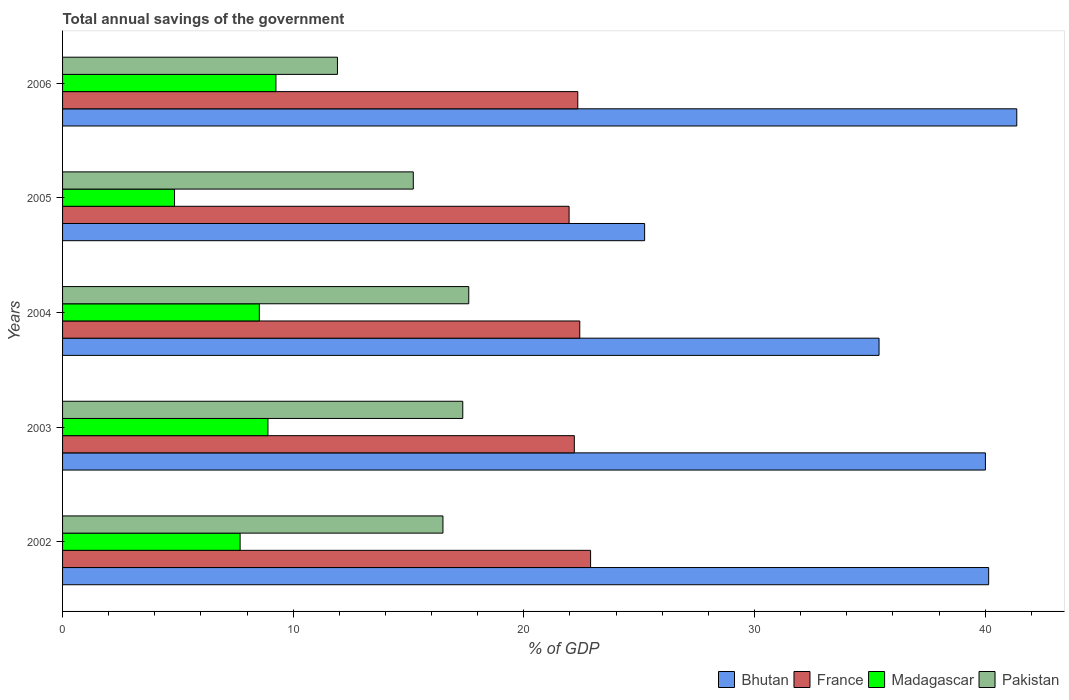How many different coloured bars are there?
Your answer should be very brief. 4. How many groups of bars are there?
Offer a terse response. 5. Are the number of bars on each tick of the Y-axis equal?
Offer a terse response. Yes. How many bars are there on the 3rd tick from the top?
Ensure brevity in your answer.  4. How many bars are there on the 1st tick from the bottom?
Your answer should be compact. 4. What is the label of the 1st group of bars from the top?
Give a very brief answer. 2006. In how many cases, is the number of bars for a given year not equal to the number of legend labels?
Provide a succinct answer. 0. What is the total annual savings of the government in France in 2003?
Provide a succinct answer. 22.19. Across all years, what is the maximum total annual savings of the government in Madagascar?
Offer a very short reply. 9.25. Across all years, what is the minimum total annual savings of the government in Pakistan?
Your answer should be compact. 11.92. What is the total total annual savings of the government in Bhutan in the graph?
Your answer should be very brief. 182.17. What is the difference between the total annual savings of the government in France in 2003 and that in 2005?
Offer a very short reply. 0.23. What is the difference between the total annual savings of the government in Bhutan in 2004 and the total annual savings of the government in Madagascar in 2005?
Your answer should be compact. 30.55. What is the average total annual savings of the government in Madagascar per year?
Ensure brevity in your answer.  7.85. In the year 2002, what is the difference between the total annual savings of the government in Pakistan and total annual savings of the government in France?
Give a very brief answer. -6.4. What is the ratio of the total annual savings of the government in France in 2002 to that in 2005?
Give a very brief answer. 1.04. Is the difference between the total annual savings of the government in Pakistan in 2002 and 2006 greater than the difference between the total annual savings of the government in France in 2002 and 2006?
Keep it short and to the point. Yes. What is the difference between the highest and the second highest total annual savings of the government in Madagascar?
Provide a short and direct response. 0.35. What is the difference between the highest and the lowest total annual savings of the government in France?
Keep it short and to the point. 0.93. In how many years, is the total annual savings of the government in Madagascar greater than the average total annual savings of the government in Madagascar taken over all years?
Offer a terse response. 3. What does the 4th bar from the top in 2005 represents?
Give a very brief answer. Bhutan. How many bars are there?
Make the answer very short. 20. Are all the bars in the graph horizontal?
Make the answer very short. Yes. How many years are there in the graph?
Offer a terse response. 5. What is the difference between two consecutive major ticks on the X-axis?
Your response must be concise. 10. Does the graph contain any zero values?
Offer a very short reply. No. How many legend labels are there?
Your answer should be very brief. 4. How are the legend labels stacked?
Ensure brevity in your answer.  Horizontal. What is the title of the graph?
Keep it short and to the point. Total annual savings of the government. Does "Gabon" appear as one of the legend labels in the graph?
Ensure brevity in your answer.  No. What is the label or title of the X-axis?
Offer a terse response. % of GDP. What is the label or title of the Y-axis?
Offer a very short reply. Years. What is the % of GDP in Bhutan in 2002?
Offer a terse response. 40.15. What is the % of GDP of France in 2002?
Give a very brief answer. 22.89. What is the % of GDP of Madagascar in 2002?
Give a very brief answer. 7.7. What is the % of GDP of Pakistan in 2002?
Your answer should be very brief. 16.49. What is the % of GDP of Bhutan in 2003?
Provide a short and direct response. 40.01. What is the % of GDP in France in 2003?
Offer a terse response. 22.19. What is the % of GDP in Madagascar in 2003?
Your answer should be compact. 8.91. What is the % of GDP of Pakistan in 2003?
Ensure brevity in your answer.  17.35. What is the % of GDP in Bhutan in 2004?
Provide a succinct answer. 35.4. What is the % of GDP in France in 2004?
Provide a short and direct response. 22.42. What is the % of GDP in Madagascar in 2004?
Make the answer very short. 8.53. What is the % of GDP in Pakistan in 2004?
Provide a short and direct response. 17.61. What is the % of GDP of Bhutan in 2005?
Make the answer very short. 25.24. What is the % of GDP in France in 2005?
Your response must be concise. 21.96. What is the % of GDP in Madagascar in 2005?
Ensure brevity in your answer.  4.85. What is the % of GDP of Pakistan in 2005?
Keep it short and to the point. 15.21. What is the % of GDP in Bhutan in 2006?
Your answer should be compact. 41.37. What is the % of GDP in France in 2006?
Provide a succinct answer. 22.34. What is the % of GDP of Madagascar in 2006?
Make the answer very short. 9.25. What is the % of GDP in Pakistan in 2006?
Your answer should be very brief. 11.92. Across all years, what is the maximum % of GDP in Bhutan?
Your answer should be very brief. 41.37. Across all years, what is the maximum % of GDP of France?
Keep it short and to the point. 22.89. Across all years, what is the maximum % of GDP in Madagascar?
Offer a terse response. 9.25. Across all years, what is the maximum % of GDP in Pakistan?
Provide a succinct answer. 17.61. Across all years, what is the minimum % of GDP of Bhutan?
Ensure brevity in your answer.  25.24. Across all years, what is the minimum % of GDP of France?
Your answer should be compact. 21.96. Across all years, what is the minimum % of GDP in Madagascar?
Offer a terse response. 4.85. Across all years, what is the minimum % of GDP in Pakistan?
Your answer should be very brief. 11.92. What is the total % of GDP in Bhutan in the graph?
Make the answer very short. 182.17. What is the total % of GDP of France in the graph?
Ensure brevity in your answer.  111.81. What is the total % of GDP in Madagascar in the graph?
Offer a very short reply. 39.24. What is the total % of GDP in Pakistan in the graph?
Your answer should be very brief. 78.58. What is the difference between the % of GDP of Bhutan in 2002 and that in 2003?
Make the answer very short. 0.14. What is the difference between the % of GDP in France in 2002 and that in 2003?
Provide a succinct answer. 0.71. What is the difference between the % of GDP in Madagascar in 2002 and that in 2003?
Provide a succinct answer. -1.21. What is the difference between the % of GDP in Pakistan in 2002 and that in 2003?
Keep it short and to the point. -0.86. What is the difference between the % of GDP of Bhutan in 2002 and that in 2004?
Give a very brief answer. 4.75. What is the difference between the % of GDP of France in 2002 and that in 2004?
Make the answer very short. 0.47. What is the difference between the % of GDP in Madagascar in 2002 and that in 2004?
Provide a short and direct response. -0.83. What is the difference between the % of GDP in Pakistan in 2002 and that in 2004?
Give a very brief answer. -1.12. What is the difference between the % of GDP of Bhutan in 2002 and that in 2005?
Your answer should be compact. 14.92. What is the difference between the % of GDP of France in 2002 and that in 2005?
Give a very brief answer. 0.93. What is the difference between the % of GDP of Madagascar in 2002 and that in 2005?
Make the answer very short. 2.84. What is the difference between the % of GDP in Pakistan in 2002 and that in 2005?
Your answer should be compact. 1.29. What is the difference between the % of GDP of Bhutan in 2002 and that in 2006?
Offer a very short reply. -1.22. What is the difference between the % of GDP of France in 2002 and that in 2006?
Give a very brief answer. 0.56. What is the difference between the % of GDP in Madagascar in 2002 and that in 2006?
Offer a terse response. -1.55. What is the difference between the % of GDP of Pakistan in 2002 and that in 2006?
Your answer should be compact. 4.57. What is the difference between the % of GDP in Bhutan in 2003 and that in 2004?
Offer a terse response. 4.61. What is the difference between the % of GDP of France in 2003 and that in 2004?
Offer a very short reply. -0.24. What is the difference between the % of GDP of Madagascar in 2003 and that in 2004?
Keep it short and to the point. 0.37. What is the difference between the % of GDP in Pakistan in 2003 and that in 2004?
Provide a succinct answer. -0.26. What is the difference between the % of GDP in Bhutan in 2003 and that in 2005?
Offer a very short reply. 14.78. What is the difference between the % of GDP of France in 2003 and that in 2005?
Your answer should be compact. 0.23. What is the difference between the % of GDP in Madagascar in 2003 and that in 2005?
Make the answer very short. 4.05. What is the difference between the % of GDP in Pakistan in 2003 and that in 2005?
Keep it short and to the point. 2.14. What is the difference between the % of GDP in Bhutan in 2003 and that in 2006?
Your answer should be very brief. -1.36. What is the difference between the % of GDP in France in 2003 and that in 2006?
Provide a short and direct response. -0.15. What is the difference between the % of GDP of Madagascar in 2003 and that in 2006?
Provide a succinct answer. -0.35. What is the difference between the % of GDP of Pakistan in 2003 and that in 2006?
Offer a very short reply. 5.43. What is the difference between the % of GDP of Bhutan in 2004 and that in 2005?
Provide a succinct answer. 10.16. What is the difference between the % of GDP of France in 2004 and that in 2005?
Ensure brevity in your answer.  0.46. What is the difference between the % of GDP of Madagascar in 2004 and that in 2005?
Provide a succinct answer. 3.68. What is the difference between the % of GDP in Pakistan in 2004 and that in 2005?
Provide a short and direct response. 2.4. What is the difference between the % of GDP in Bhutan in 2004 and that in 2006?
Make the answer very short. -5.97. What is the difference between the % of GDP of France in 2004 and that in 2006?
Your answer should be compact. 0.09. What is the difference between the % of GDP of Madagascar in 2004 and that in 2006?
Ensure brevity in your answer.  -0.72. What is the difference between the % of GDP of Pakistan in 2004 and that in 2006?
Provide a succinct answer. 5.69. What is the difference between the % of GDP of Bhutan in 2005 and that in 2006?
Keep it short and to the point. -16.14. What is the difference between the % of GDP of France in 2005 and that in 2006?
Offer a very short reply. -0.38. What is the difference between the % of GDP of Madagascar in 2005 and that in 2006?
Give a very brief answer. -4.4. What is the difference between the % of GDP of Pakistan in 2005 and that in 2006?
Your answer should be very brief. 3.29. What is the difference between the % of GDP of Bhutan in 2002 and the % of GDP of France in 2003?
Make the answer very short. 17.96. What is the difference between the % of GDP in Bhutan in 2002 and the % of GDP in Madagascar in 2003?
Make the answer very short. 31.25. What is the difference between the % of GDP of Bhutan in 2002 and the % of GDP of Pakistan in 2003?
Your response must be concise. 22.8. What is the difference between the % of GDP of France in 2002 and the % of GDP of Madagascar in 2003?
Give a very brief answer. 13.99. What is the difference between the % of GDP in France in 2002 and the % of GDP in Pakistan in 2003?
Provide a short and direct response. 5.54. What is the difference between the % of GDP in Madagascar in 2002 and the % of GDP in Pakistan in 2003?
Your answer should be compact. -9.65. What is the difference between the % of GDP in Bhutan in 2002 and the % of GDP in France in 2004?
Give a very brief answer. 17.73. What is the difference between the % of GDP in Bhutan in 2002 and the % of GDP in Madagascar in 2004?
Ensure brevity in your answer.  31.62. What is the difference between the % of GDP in Bhutan in 2002 and the % of GDP in Pakistan in 2004?
Provide a short and direct response. 22.54. What is the difference between the % of GDP of France in 2002 and the % of GDP of Madagascar in 2004?
Your answer should be compact. 14.36. What is the difference between the % of GDP of France in 2002 and the % of GDP of Pakistan in 2004?
Provide a short and direct response. 5.28. What is the difference between the % of GDP of Madagascar in 2002 and the % of GDP of Pakistan in 2004?
Provide a succinct answer. -9.91. What is the difference between the % of GDP of Bhutan in 2002 and the % of GDP of France in 2005?
Your answer should be compact. 18.19. What is the difference between the % of GDP of Bhutan in 2002 and the % of GDP of Madagascar in 2005?
Ensure brevity in your answer.  35.3. What is the difference between the % of GDP in Bhutan in 2002 and the % of GDP in Pakistan in 2005?
Your answer should be very brief. 24.95. What is the difference between the % of GDP of France in 2002 and the % of GDP of Madagascar in 2005?
Offer a very short reply. 18.04. What is the difference between the % of GDP of France in 2002 and the % of GDP of Pakistan in 2005?
Provide a short and direct response. 7.69. What is the difference between the % of GDP of Madagascar in 2002 and the % of GDP of Pakistan in 2005?
Provide a short and direct response. -7.51. What is the difference between the % of GDP in Bhutan in 2002 and the % of GDP in France in 2006?
Provide a succinct answer. 17.81. What is the difference between the % of GDP of Bhutan in 2002 and the % of GDP of Madagascar in 2006?
Your response must be concise. 30.9. What is the difference between the % of GDP of Bhutan in 2002 and the % of GDP of Pakistan in 2006?
Ensure brevity in your answer.  28.23. What is the difference between the % of GDP of France in 2002 and the % of GDP of Madagascar in 2006?
Your answer should be compact. 13.64. What is the difference between the % of GDP in France in 2002 and the % of GDP in Pakistan in 2006?
Give a very brief answer. 10.98. What is the difference between the % of GDP in Madagascar in 2002 and the % of GDP in Pakistan in 2006?
Your answer should be very brief. -4.22. What is the difference between the % of GDP in Bhutan in 2003 and the % of GDP in France in 2004?
Provide a succinct answer. 17.59. What is the difference between the % of GDP in Bhutan in 2003 and the % of GDP in Madagascar in 2004?
Provide a succinct answer. 31.48. What is the difference between the % of GDP of Bhutan in 2003 and the % of GDP of Pakistan in 2004?
Provide a short and direct response. 22.4. What is the difference between the % of GDP of France in 2003 and the % of GDP of Madagascar in 2004?
Provide a succinct answer. 13.66. What is the difference between the % of GDP in France in 2003 and the % of GDP in Pakistan in 2004?
Offer a terse response. 4.58. What is the difference between the % of GDP in Madagascar in 2003 and the % of GDP in Pakistan in 2004?
Offer a terse response. -8.71. What is the difference between the % of GDP of Bhutan in 2003 and the % of GDP of France in 2005?
Provide a short and direct response. 18.05. What is the difference between the % of GDP in Bhutan in 2003 and the % of GDP in Madagascar in 2005?
Ensure brevity in your answer.  35.16. What is the difference between the % of GDP of Bhutan in 2003 and the % of GDP of Pakistan in 2005?
Offer a terse response. 24.8. What is the difference between the % of GDP in France in 2003 and the % of GDP in Madagascar in 2005?
Keep it short and to the point. 17.33. What is the difference between the % of GDP in France in 2003 and the % of GDP in Pakistan in 2005?
Your response must be concise. 6.98. What is the difference between the % of GDP in Madagascar in 2003 and the % of GDP in Pakistan in 2005?
Offer a very short reply. -6.3. What is the difference between the % of GDP of Bhutan in 2003 and the % of GDP of France in 2006?
Give a very brief answer. 17.67. What is the difference between the % of GDP in Bhutan in 2003 and the % of GDP in Madagascar in 2006?
Your answer should be compact. 30.76. What is the difference between the % of GDP of Bhutan in 2003 and the % of GDP of Pakistan in 2006?
Make the answer very short. 28.09. What is the difference between the % of GDP of France in 2003 and the % of GDP of Madagascar in 2006?
Offer a terse response. 12.94. What is the difference between the % of GDP in France in 2003 and the % of GDP in Pakistan in 2006?
Provide a succinct answer. 10.27. What is the difference between the % of GDP of Madagascar in 2003 and the % of GDP of Pakistan in 2006?
Keep it short and to the point. -3.01. What is the difference between the % of GDP in Bhutan in 2004 and the % of GDP in France in 2005?
Provide a succinct answer. 13.44. What is the difference between the % of GDP of Bhutan in 2004 and the % of GDP of Madagascar in 2005?
Provide a succinct answer. 30.55. What is the difference between the % of GDP in Bhutan in 2004 and the % of GDP in Pakistan in 2005?
Give a very brief answer. 20.19. What is the difference between the % of GDP of France in 2004 and the % of GDP of Madagascar in 2005?
Offer a terse response. 17.57. What is the difference between the % of GDP of France in 2004 and the % of GDP of Pakistan in 2005?
Your answer should be very brief. 7.22. What is the difference between the % of GDP in Madagascar in 2004 and the % of GDP in Pakistan in 2005?
Make the answer very short. -6.68. What is the difference between the % of GDP in Bhutan in 2004 and the % of GDP in France in 2006?
Offer a terse response. 13.06. What is the difference between the % of GDP in Bhutan in 2004 and the % of GDP in Madagascar in 2006?
Offer a very short reply. 26.15. What is the difference between the % of GDP of Bhutan in 2004 and the % of GDP of Pakistan in 2006?
Keep it short and to the point. 23.48. What is the difference between the % of GDP of France in 2004 and the % of GDP of Madagascar in 2006?
Give a very brief answer. 13.17. What is the difference between the % of GDP in France in 2004 and the % of GDP in Pakistan in 2006?
Make the answer very short. 10.51. What is the difference between the % of GDP in Madagascar in 2004 and the % of GDP in Pakistan in 2006?
Provide a succinct answer. -3.39. What is the difference between the % of GDP in Bhutan in 2005 and the % of GDP in France in 2006?
Give a very brief answer. 2.9. What is the difference between the % of GDP of Bhutan in 2005 and the % of GDP of Madagascar in 2006?
Your response must be concise. 15.98. What is the difference between the % of GDP of Bhutan in 2005 and the % of GDP of Pakistan in 2006?
Provide a succinct answer. 13.32. What is the difference between the % of GDP of France in 2005 and the % of GDP of Madagascar in 2006?
Give a very brief answer. 12.71. What is the difference between the % of GDP of France in 2005 and the % of GDP of Pakistan in 2006?
Your response must be concise. 10.04. What is the difference between the % of GDP in Madagascar in 2005 and the % of GDP in Pakistan in 2006?
Ensure brevity in your answer.  -7.06. What is the average % of GDP in Bhutan per year?
Offer a very short reply. 36.43. What is the average % of GDP in France per year?
Your answer should be compact. 22.36. What is the average % of GDP of Madagascar per year?
Offer a terse response. 7.85. What is the average % of GDP of Pakistan per year?
Keep it short and to the point. 15.72. In the year 2002, what is the difference between the % of GDP of Bhutan and % of GDP of France?
Your answer should be compact. 17.26. In the year 2002, what is the difference between the % of GDP of Bhutan and % of GDP of Madagascar?
Make the answer very short. 32.45. In the year 2002, what is the difference between the % of GDP of Bhutan and % of GDP of Pakistan?
Make the answer very short. 23.66. In the year 2002, what is the difference between the % of GDP in France and % of GDP in Madagascar?
Ensure brevity in your answer.  15.2. In the year 2002, what is the difference between the % of GDP of France and % of GDP of Pakistan?
Your response must be concise. 6.4. In the year 2002, what is the difference between the % of GDP in Madagascar and % of GDP in Pakistan?
Ensure brevity in your answer.  -8.79. In the year 2003, what is the difference between the % of GDP in Bhutan and % of GDP in France?
Keep it short and to the point. 17.82. In the year 2003, what is the difference between the % of GDP in Bhutan and % of GDP in Madagascar?
Your response must be concise. 31.11. In the year 2003, what is the difference between the % of GDP in Bhutan and % of GDP in Pakistan?
Provide a short and direct response. 22.66. In the year 2003, what is the difference between the % of GDP in France and % of GDP in Madagascar?
Offer a terse response. 13.28. In the year 2003, what is the difference between the % of GDP in France and % of GDP in Pakistan?
Keep it short and to the point. 4.84. In the year 2003, what is the difference between the % of GDP of Madagascar and % of GDP of Pakistan?
Provide a succinct answer. -8.45. In the year 2004, what is the difference between the % of GDP of Bhutan and % of GDP of France?
Provide a succinct answer. 12.98. In the year 2004, what is the difference between the % of GDP in Bhutan and % of GDP in Madagascar?
Your response must be concise. 26.87. In the year 2004, what is the difference between the % of GDP of Bhutan and % of GDP of Pakistan?
Offer a very short reply. 17.79. In the year 2004, what is the difference between the % of GDP of France and % of GDP of Madagascar?
Keep it short and to the point. 13.89. In the year 2004, what is the difference between the % of GDP in France and % of GDP in Pakistan?
Ensure brevity in your answer.  4.81. In the year 2004, what is the difference between the % of GDP in Madagascar and % of GDP in Pakistan?
Keep it short and to the point. -9.08. In the year 2005, what is the difference between the % of GDP of Bhutan and % of GDP of France?
Make the answer very short. 3.27. In the year 2005, what is the difference between the % of GDP of Bhutan and % of GDP of Madagascar?
Your answer should be compact. 20.38. In the year 2005, what is the difference between the % of GDP in Bhutan and % of GDP in Pakistan?
Make the answer very short. 10.03. In the year 2005, what is the difference between the % of GDP of France and % of GDP of Madagascar?
Make the answer very short. 17.11. In the year 2005, what is the difference between the % of GDP in France and % of GDP in Pakistan?
Keep it short and to the point. 6.75. In the year 2005, what is the difference between the % of GDP of Madagascar and % of GDP of Pakistan?
Make the answer very short. -10.35. In the year 2006, what is the difference between the % of GDP in Bhutan and % of GDP in France?
Provide a succinct answer. 19.03. In the year 2006, what is the difference between the % of GDP of Bhutan and % of GDP of Madagascar?
Provide a short and direct response. 32.12. In the year 2006, what is the difference between the % of GDP of Bhutan and % of GDP of Pakistan?
Make the answer very short. 29.45. In the year 2006, what is the difference between the % of GDP of France and % of GDP of Madagascar?
Provide a short and direct response. 13.09. In the year 2006, what is the difference between the % of GDP in France and % of GDP in Pakistan?
Give a very brief answer. 10.42. In the year 2006, what is the difference between the % of GDP in Madagascar and % of GDP in Pakistan?
Your answer should be very brief. -2.67. What is the ratio of the % of GDP in Bhutan in 2002 to that in 2003?
Your answer should be very brief. 1. What is the ratio of the % of GDP in France in 2002 to that in 2003?
Provide a succinct answer. 1.03. What is the ratio of the % of GDP in Madagascar in 2002 to that in 2003?
Ensure brevity in your answer.  0.86. What is the ratio of the % of GDP of Pakistan in 2002 to that in 2003?
Provide a short and direct response. 0.95. What is the ratio of the % of GDP in Bhutan in 2002 to that in 2004?
Provide a short and direct response. 1.13. What is the ratio of the % of GDP of France in 2002 to that in 2004?
Your response must be concise. 1.02. What is the ratio of the % of GDP in Madagascar in 2002 to that in 2004?
Give a very brief answer. 0.9. What is the ratio of the % of GDP in Pakistan in 2002 to that in 2004?
Offer a terse response. 0.94. What is the ratio of the % of GDP of Bhutan in 2002 to that in 2005?
Offer a terse response. 1.59. What is the ratio of the % of GDP of France in 2002 to that in 2005?
Your answer should be very brief. 1.04. What is the ratio of the % of GDP of Madagascar in 2002 to that in 2005?
Your answer should be compact. 1.59. What is the ratio of the % of GDP in Pakistan in 2002 to that in 2005?
Offer a very short reply. 1.08. What is the ratio of the % of GDP of Bhutan in 2002 to that in 2006?
Make the answer very short. 0.97. What is the ratio of the % of GDP of France in 2002 to that in 2006?
Offer a terse response. 1.02. What is the ratio of the % of GDP of Madagascar in 2002 to that in 2006?
Your answer should be very brief. 0.83. What is the ratio of the % of GDP in Pakistan in 2002 to that in 2006?
Offer a very short reply. 1.38. What is the ratio of the % of GDP of Bhutan in 2003 to that in 2004?
Offer a very short reply. 1.13. What is the ratio of the % of GDP of Madagascar in 2003 to that in 2004?
Provide a short and direct response. 1.04. What is the ratio of the % of GDP in Pakistan in 2003 to that in 2004?
Offer a very short reply. 0.99. What is the ratio of the % of GDP in Bhutan in 2003 to that in 2005?
Your response must be concise. 1.59. What is the ratio of the % of GDP in France in 2003 to that in 2005?
Your response must be concise. 1.01. What is the ratio of the % of GDP of Madagascar in 2003 to that in 2005?
Keep it short and to the point. 1.83. What is the ratio of the % of GDP of Pakistan in 2003 to that in 2005?
Your response must be concise. 1.14. What is the ratio of the % of GDP in Bhutan in 2003 to that in 2006?
Your answer should be compact. 0.97. What is the ratio of the % of GDP of France in 2003 to that in 2006?
Your response must be concise. 0.99. What is the ratio of the % of GDP in Madagascar in 2003 to that in 2006?
Provide a short and direct response. 0.96. What is the ratio of the % of GDP in Pakistan in 2003 to that in 2006?
Offer a very short reply. 1.46. What is the ratio of the % of GDP in Bhutan in 2004 to that in 2005?
Your answer should be compact. 1.4. What is the ratio of the % of GDP of France in 2004 to that in 2005?
Provide a succinct answer. 1.02. What is the ratio of the % of GDP in Madagascar in 2004 to that in 2005?
Your answer should be compact. 1.76. What is the ratio of the % of GDP in Pakistan in 2004 to that in 2005?
Keep it short and to the point. 1.16. What is the ratio of the % of GDP in Bhutan in 2004 to that in 2006?
Give a very brief answer. 0.86. What is the ratio of the % of GDP in France in 2004 to that in 2006?
Provide a succinct answer. 1. What is the ratio of the % of GDP in Madagascar in 2004 to that in 2006?
Offer a terse response. 0.92. What is the ratio of the % of GDP in Pakistan in 2004 to that in 2006?
Your response must be concise. 1.48. What is the ratio of the % of GDP in Bhutan in 2005 to that in 2006?
Your answer should be very brief. 0.61. What is the ratio of the % of GDP of France in 2005 to that in 2006?
Your answer should be compact. 0.98. What is the ratio of the % of GDP of Madagascar in 2005 to that in 2006?
Ensure brevity in your answer.  0.52. What is the ratio of the % of GDP of Pakistan in 2005 to that in 2006?
Offer a very short reply. 1.28. What is the difference between the highest and the second highest % of GDP of Bhutan?
Your answer should be compact. 1.22. What is the difference between the highest and the second highest % of GDP of France?
Give a very brief answer. 0.47. What is the difference between the highest and the second highest % of GDP in Madagascar?
Provide a succinct answer. 0.35. What is the difference between the highest and the second highest % of GDP in Pakistan?
Your answer should be very brief. 0.26. What is the difference between the highest and the lowest % of GDP in Bhutan?
Ensure brevity in your answer.  16.14. What is the difference between the highest and the lowest % of GDP of France?
Your response must be concise. 0.93. What is the difference between the highest and the lowest % of GDP in Madagascar?
Keep it short and to the point. 4.4. What is the difference between the highest and the lowest % of GDP of Pakistan?
Your response must be concise. 5.69. 